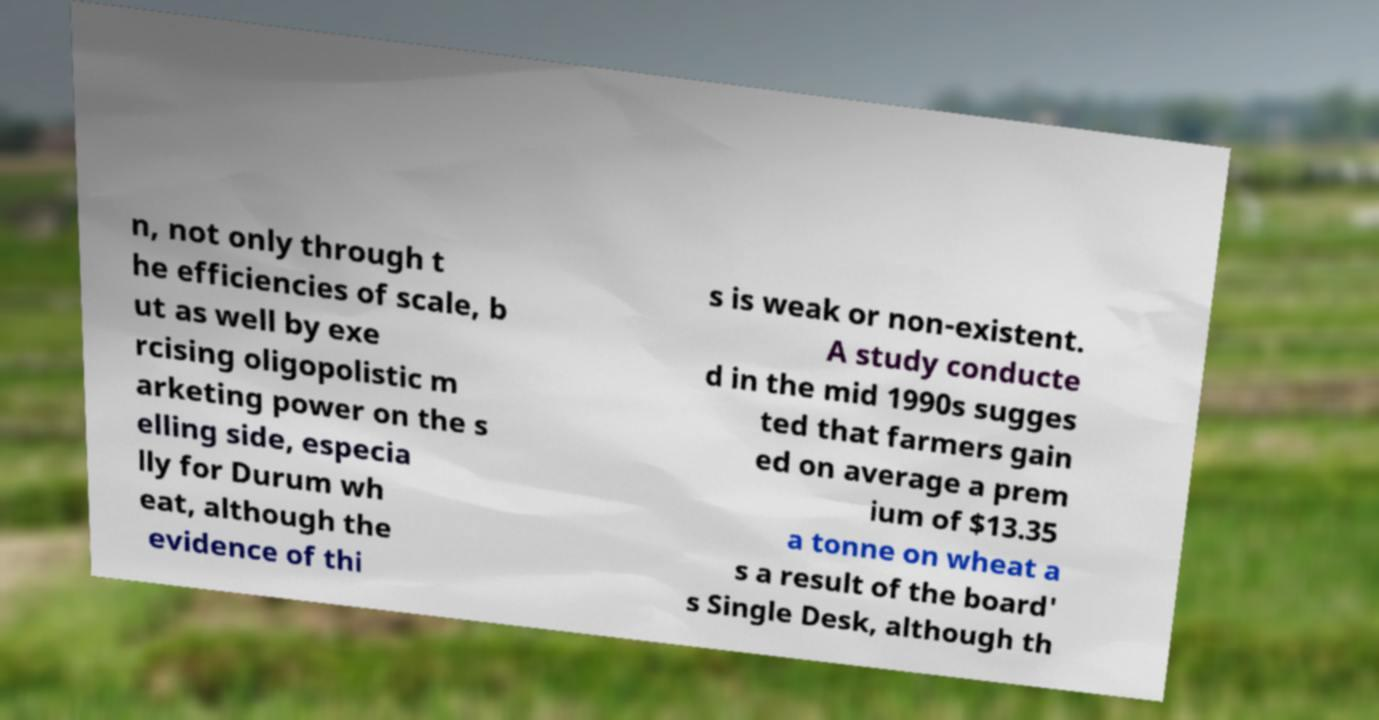Can you read and provide the text displayed in the image?This photo seems to have some interesting text. Can you extract and type it out for me? n, not only through t he efficiencies of scale, b ut as well by exe rcising oligopolistic m arketing power on the s elling side, especia lly for Durum wh eat, although the evidence of thi s is weak or non-existent. A study conducte d in the mid 1990s sugges ted that farmers gain ed on average a prem ium of $13.35 a tonne on wheat a s a result of the board' s Single Desk, although th 